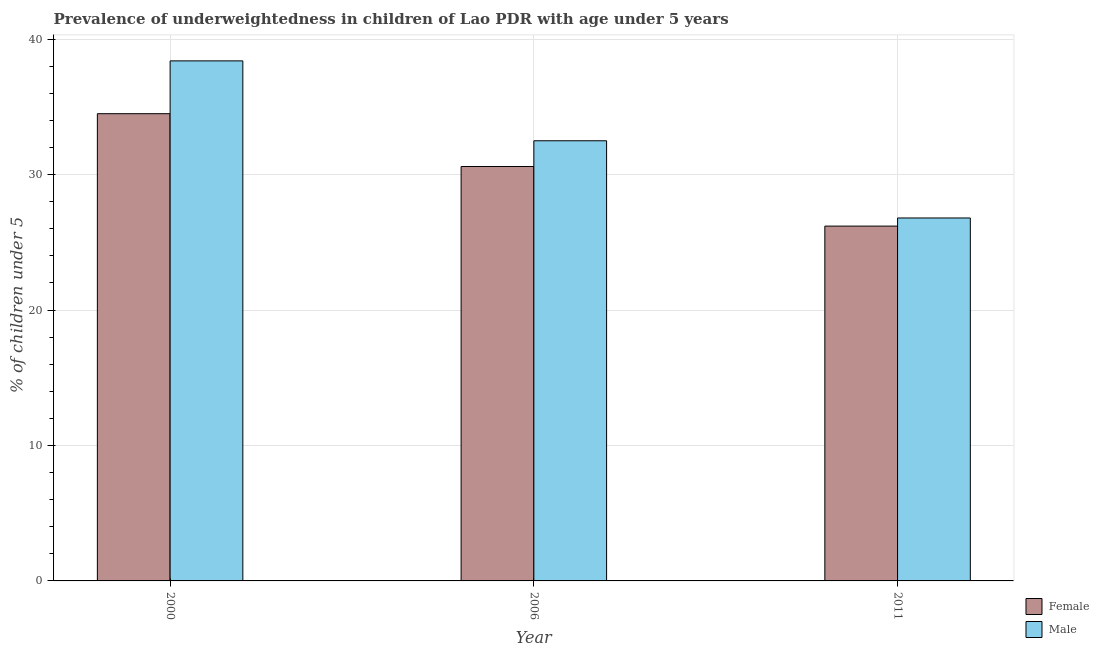How many bars are there on the 3rd tick from the left?
Your answer should be compact. 2. What is the label of the 3rd group of bars from the left?
Ensure brevity in your answer.  2011. In how many cases, is the number of bars for a given year not equal to the number of legend labels?
Your answer should be compact. 0. What is the percentage of underweighted female children in 2011?
Give a very brief answer. 26.2. Across all years, what is the maximum percentage of underweighted female children?
Keep it short and to the point. 34.5. Across all years, what is the minimum percentage of underweighted male children?
Your answer should be compact. 26.8. In which year was the percentage of underweighted male children maximum?
Make the answer very short. 2000. What is the total percentage of underweighted female children in the graph?
Provide a succinct answer. 91.3. What is the difference between the percentage of underweighted female children in 2000 and that in 2011?
Give a very brief answer. 8.3. What is the difference between the percentage of underweighted male children in 2006 and the percentage of underweighted female children in 2000?
Your answer should be very brief. -5.9. What is the average percentage of underweighted female children per year?
Keep it short and to the point. 30.43. In how many years, is the percentage of underweighted female children greater than 18 %?
Offer a terse response. 3. What is the ratio of the percentage of underweighted male children in 2000 to that in 2006?
Your answer should be compact. 1.18. Is the percentage of underweighted female children in 2000 less than that in 2011?
Offer a very short reply. No. What is the difference between the highest and the second highest percentage of underweighted female children?
Ensure brevity in your answer.  3.9. What is the difference between the highest and the lowest percentage of underweighted male children?
Your answer should be compact. 11.6. What does the 2nd bar from the left in 2011 represents?
Keep it short and to the point. Male. How many bars are there?
Your answer should be very brief. 6. Are all the bars in the graph horizontal?
Keep it short and to the point. No. How many years are there in the graph?
Offer a terse response. 3. Does the graph contain grids?
Your answer should be compact. Yes. How many legend labels are there?
Ensure brevity in your answer.  2. How are the legend labels stacked?
Keep it short and to the point. Vertical. What is the title of the graph?
Provide a short and direct response. Prevalence of underweightedness in children of Lao PDR with age under 5 years. Does "Females" appear as one of the legend labels in the graph?
Provide a succinct answer. No. What is the label or title of the Y-axis?
Make the answer very short.  % of children under 5. What is the  % of children under 5 of Female in 2000?
Your response must be concise. 34.5. What is the  % of children under 5 of Male in 2000?
Make the answer very short. 38.4. What is the  % of children under 5 in Female in 2006?
Make the answer very short. 30.6. What is the  % of children under 5 in Male in 2006?
Provide a short and direct response. 32.5. What is the  % of children under 5 in Female in 2011?
Your answer should be compact. 26.2. What is the  % of children under 5 of Male in 2011?
Offer a very short reply. 26.8. Across all years, what is the maximum  % of children under 5 of Female?
Keep it short and to the point. 34.5. Across all years, what is the maximum  % of children under 5 of Male?
Make the answer very short. 38.4. Across all years, what is the minimum  % of children under 5 of Female?
Your answer should be very brief. 26.2. Across all years, what is the minimum  % of children under 5 of Male?
Your answer should be very brief. 26.8. What is the total  % of children under 5 of Female in the graph?
Make the answer very short. 91.3. What is the total  % of children under 5 of Male in the graph?
Provide a succinct answer. 97.7. What is the difference between the  % of children under 5 in Female in 2000 and that in 2011?
Keep it short and to the point. 8.3. What is the difference between the  % of children under 5 in Male in 2006 and that in 2011?
Your response must be concise. 5.7. What is the difference between the  % of children under 5 of Female in 2006 and the  % of children under 5 of Male in 2011?
Your response must be concise. 3.8. What is the average  % of children under 5 in Female per year?
Your answer should be very brief. 30.43. What is the average  % of children under 5 in Male per year?
Your response must be concise. 32.57. In the year 2000, what is the difference between the  % of children under 5 of Female and  % of children under 5 of Male?
Offer a terse response. -3.9. In the year 2006, what is the difference between the  % of children under 5 in Female and  % of children under 5 in Male?
Your answer should be very brief. -1.9. What is the ratio of the  % of children under 5 of Female in 2000 to that in 2006?
Provide a short and direct response. 1.13. What is the ratio of the  % of children under 5 in Male in 2000 to that in 2006?
Make the answer very short. 1.18. What is the ratio of the  % of children under 5 of Female in 2000 to that in 2011?
Your response must be concise. 1.32. What is the ratio of the  % of children under 5 in Male in 2000 to that in 2011?
Make the answer very short. 1.43. What is the ratio of the  % of children under 5 of Female in 2006 to that in 2011?
Offer a terse response. 1.17. What is the ratio of the  % of children under 5 in Male in 2006 to that in 2011?
Your answer should be compact. 1.21. What is the difference between the highest and the second highest  % of children under 5 in Female?
Offer a very short reply. 3.9. What is the difference between the highest and the second highest  % of children under 5 of Male?
Give a very brief answer. 5.9. 